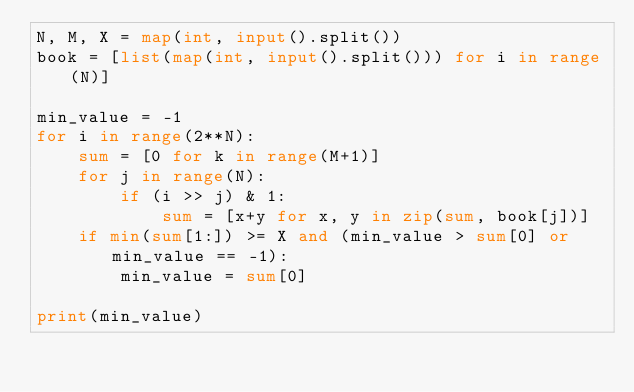<code> <loc_0><loc_0><loc_500><loc_500><_Python_>N, M, X = map(int, input().split())
book = [list(map(int, input().split())) for i in range(N)]

min_value = -1
for i in range(2**N):
    sum = [0 for k in range(M+1)]
    for j in range(N):
        if (i >> j) & 1:
            sum = [x+y for x, y in zip(sum, book[j])]
    if min(sum[1:]) >= X and (min_value > sum[0] or min_value == -1):
        min_value = sum[0]

print(min_value)
</code> 